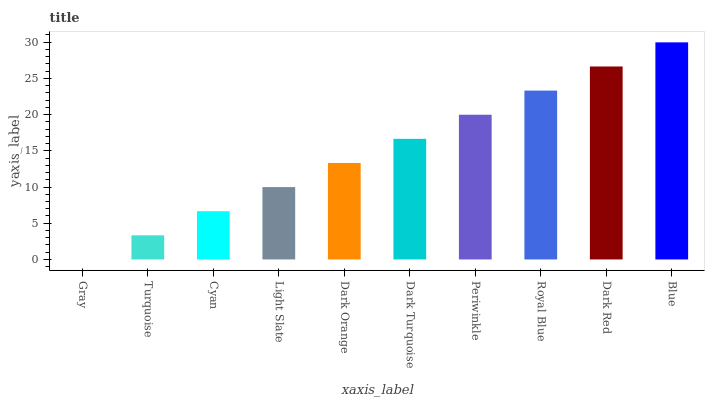Is Gray the minimum?
Answer yes or no. Yes. Is Blue the maximum?
Answer yes or no. Yes. Is Turquoise the minimum?
Answer yes or no. No. Is Turquoise the maximum?
Answer yes or no. No. Is Turquoise greater than Gray?
Answer yes or no. Yes. Is Gray less than Turquoise?
Answer yes or no. Yes. Is Gray greater than Turquoise?
Answer yes or no. No. Is Turquoise less than Gray?
Answer yes or no. No. Is Dark Turquoise the high median?
Answer yes or no. Yes. Is Dark Orange the low median?
Answer yes or no. Yes. Is Royal Blue the high median?
Answer yes or no. No. Is Gray the low median?
Answer yes or no. No. 